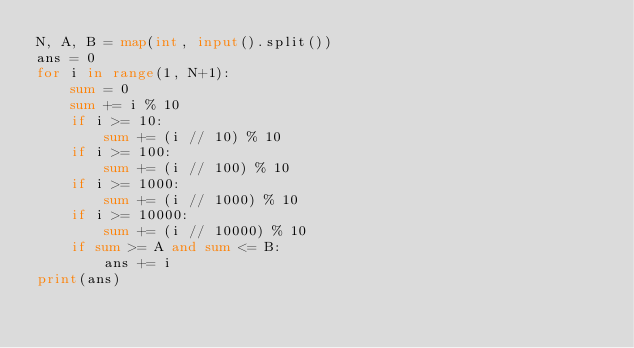Convert code to text. <code><loc_0><loc_0><loc_500><loc_500><_Python_>N, A, B = map(int, input().split())
ans = 0
for i in range(1, N+1):
    sum = 0
    sum += i % 10
    if i >= 10:
        sum += (i // 10) % 10
    if i >= 100:
        sum += (i // 100) % 10
    if i >= 1000:
        sum += (i // 1000) % 10
    if i >= 10000:
        sum += (i // 10000) % 10
    if sum >= A and sum <= B:
        ans += i
print(ans)</code> 